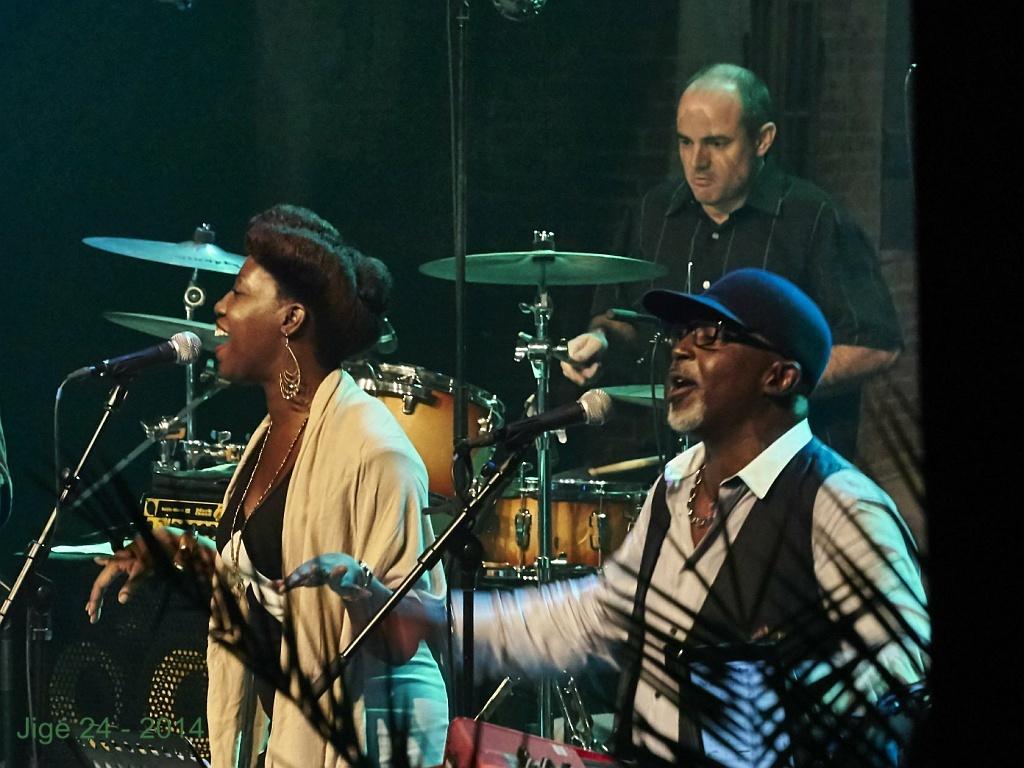Can you describe this image briefly? In this image I can see three persons and in the front of them I can see two mics. I can also see a speaker on the left side and in the background I can see a drum set. On the right side of this image I can see few black color things and on the bottom left side of this image I can see a watermark. 